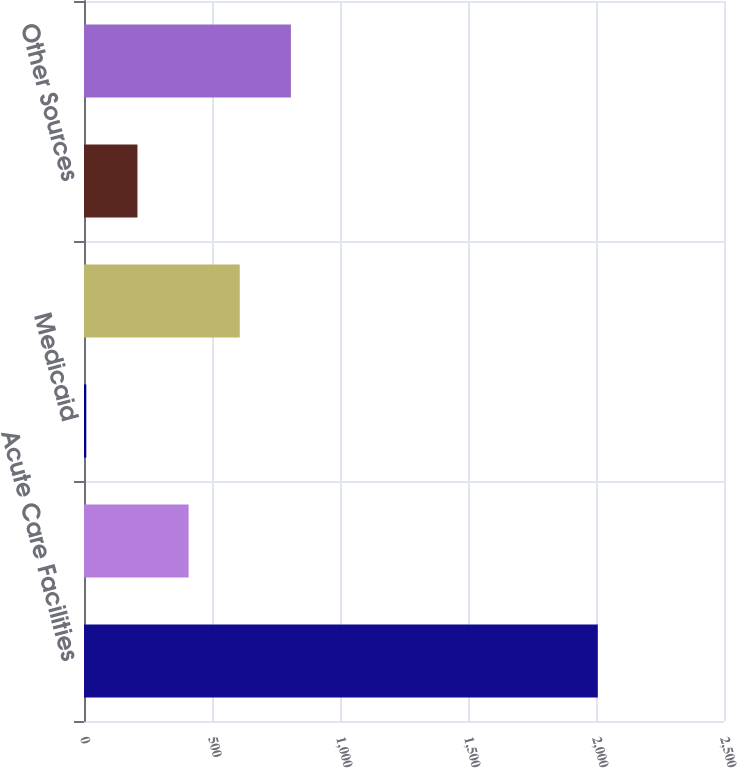Convert chart. <chart><loc_0><loc_0><loc_500><loc_500><bar_chart><fcel>Acute Care Facilities<fcel>Medicare<fcel>Medicaid<fcel>Managed Care (HMO and PPOs)<fcel>Other Sources<fcel>Total<nl><fcel>2007<fcel>408.6<fcel>9<fcel>608.4<fcel>208.8<fcel>808.2<nl></chart> 